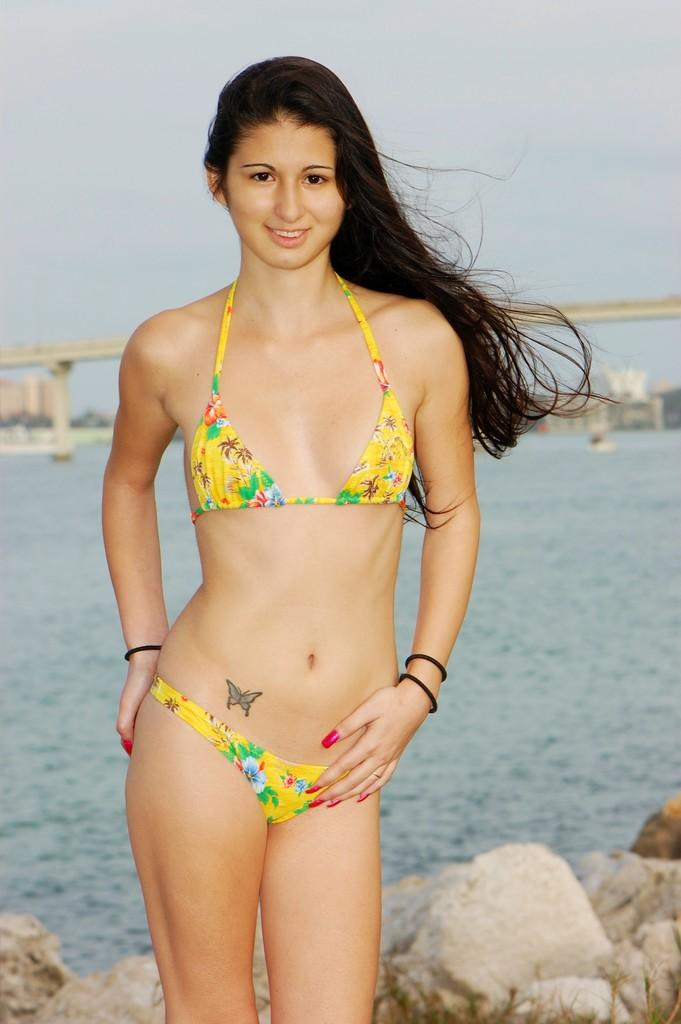Who is present in the image? There is a woman in the image. What is the woman doing in the image? The woman is standing and smiling. What type of natural elements can be seen in the image? There are stones and water visible in the image. What man-made structure is present in the image? There is a bridge in the image. What can be seen in the background of the image? There are buildings and the sky visible in the background of the image. What type of rhythm can be heard in the image? There is no sound or music present in the image, so it is not possible to determine any rhythm. 